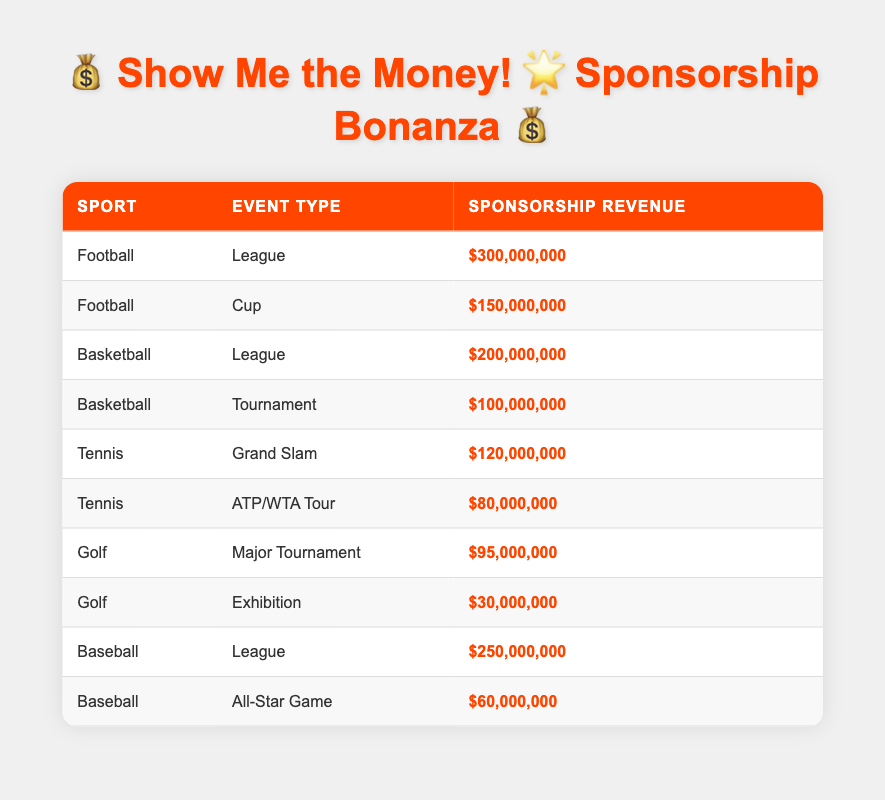What's the sponsorship revenue for Football in the League? The table shows that for Football in the League, the Sponsorship Revenue is $300,000,000, so we can directly refer to that row in the table.
Answer: 300,000,000 What is the total sponsorship revenue generated by Baseball events? We add the sponsorship revenue for both Baseball events listed in the table: League ($250,000,000) + All-Star Game ($60,000,000), which equals $310,000,000.
Answer: 310,000,000 Is the sponsorship revenue for the Tennis Grand Slam higher than that for the Golf Major Tournament? Looking at the table, the Tennis Grand Slam sponsorship revenue is $120,000,000 and for Golf Major Tournament it is $95,000,000. Since $120,000,000 is greater than $95,000,000, the statement is true.
Answer: Yes What is the difference in sponsorship revenue between the Football Cup and the Basketball League? To find the difference, we take the Football Cup's revenue ($150,000,000) and subtract the Basketball League's revenue ($200,000,000). Therefore, $150,000,000 - $200,000,000 equals a difference of -$50,000,000, which indicates Basketball League has more revenue.
Answer: -50,000,000 Which sport generated the highest sponsorship revenue from its league events? Examining the table, Football League has $300,000,000 and Baseball League has $250,000,000. Since $300,000,000 is the highest, Football generated the most revenue from its league events.
Answer: Football What is the average sponsorship revenue for the Tennis events? There are two Tennis events listed: Grand Slam ($120,000,000) and ATP/WTA Tour ($80,000,000). Adding them gives $200,000,000. Since there are 2 events, we divide $200,000,000 by 2 to get the average, which is $100,000,000.
Answer: 100,000,000 Does the Golf Exhibition event generate at least $40,000,000 in sponsorship revenue? The Golf Exhibition revenue from the table is $30,000,000, which is less than $40,000,000. So the statement is false.
Answer: No If we combine the sponsorship revenue from just the League events across all sports, what would it be? The League revenues are: Football ($300,000,000), Basketball ($200,000,000), Baseball ($250,000,000). Adding these together gives $300,000,000 + $200,000,000 + $250,000,000 = $750,000,000.
Answer: 750,000,000 